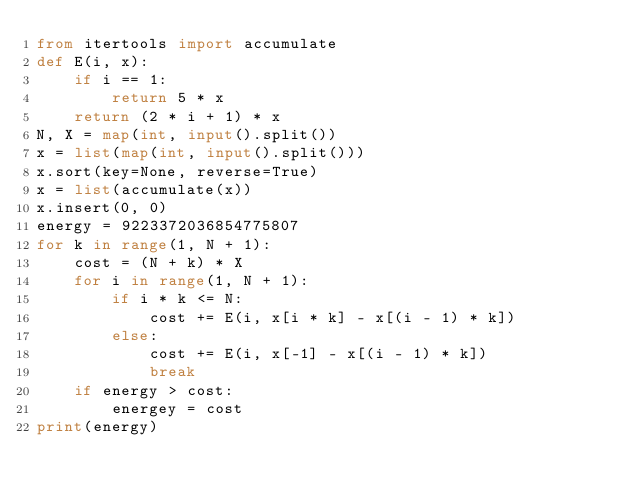<code> <loc_0><loc_0><loc_500><loc_500><_Python_>from itertools import accumulate
def E(i, x):
    if i == 1:
        return 5 * x
    return (2 * i + 1) * x
N, X = map(int, input().split())
x = list(map(int, input().split()))
x.sort(key=None, reverse=True)
x = list(accumulate(x))
x.insert(0, 0)
energy = 9223372036854775807
for k in range(1, N + 1):
    cost = (N + k) * X
    for i in range(1, N + 1):
        if i * k <= N:
            cost += E(i, x[i * k] - x[(i - 1) * k])
        else:
            cost += E(i, x[-1] - x[(i - 1) * k])
            break
    if energy > cost:
        energey = cost
print(energy)
</code> 